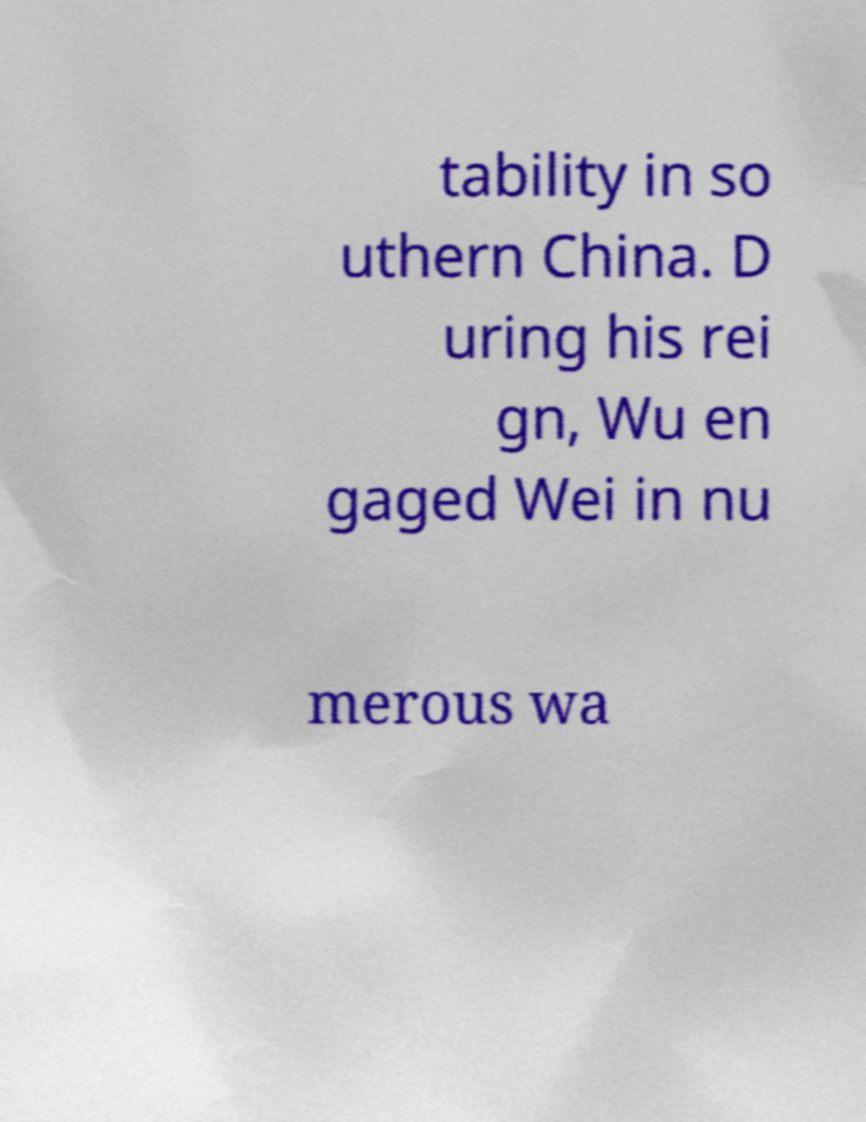Can you accurately transcribe the text from the provided image for me? tability in so uthern China. D uring his rei gn, Wu en gaged Wei in nu merous wa 